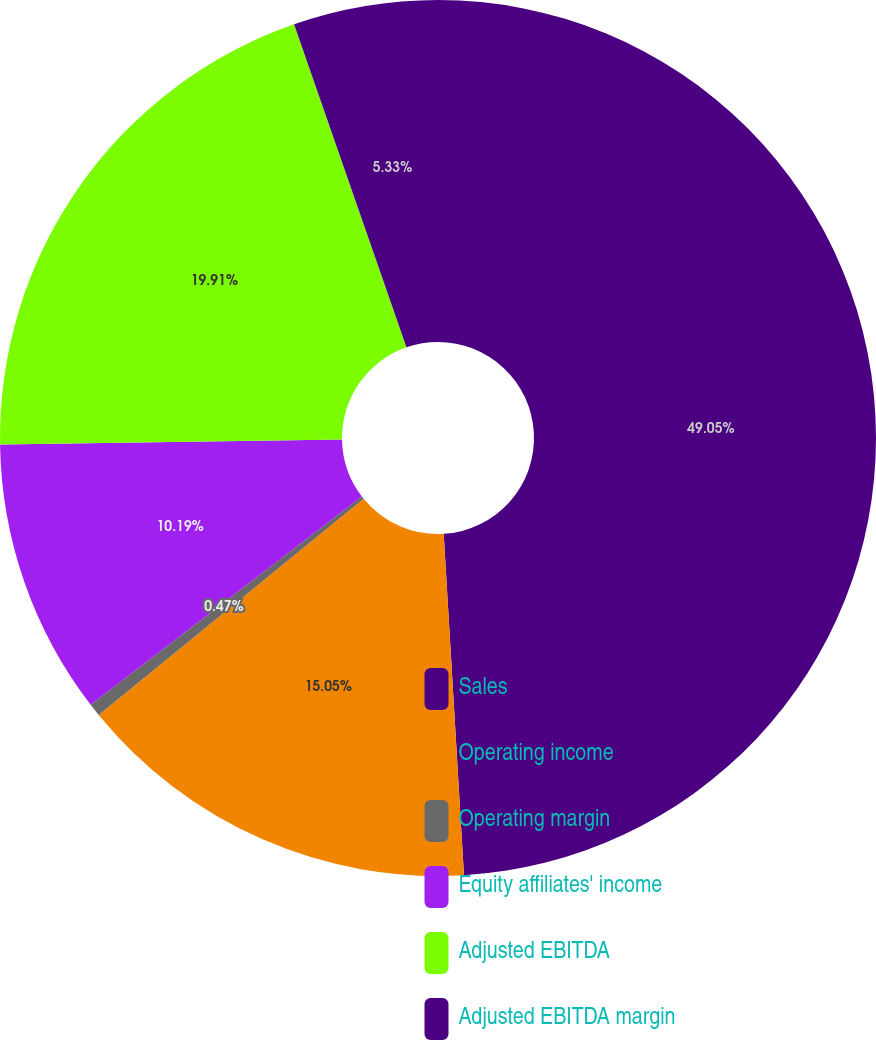<chart> <loc_0><loc_0><loc_500><loc_500><pie_chart><fcel>Sales<fcel>Operating income<fcel>Operating margin<fcel>Equity affiliates' income<fcel>Adjusted EBITDA<fcel>Adjusted EBITDA margin<nl><fcel>49.06%<fcel>15.05%<fcel>0.47%<fcel>10.19%<fcel>19.91%<fcel>5.33%<nl></chart> 